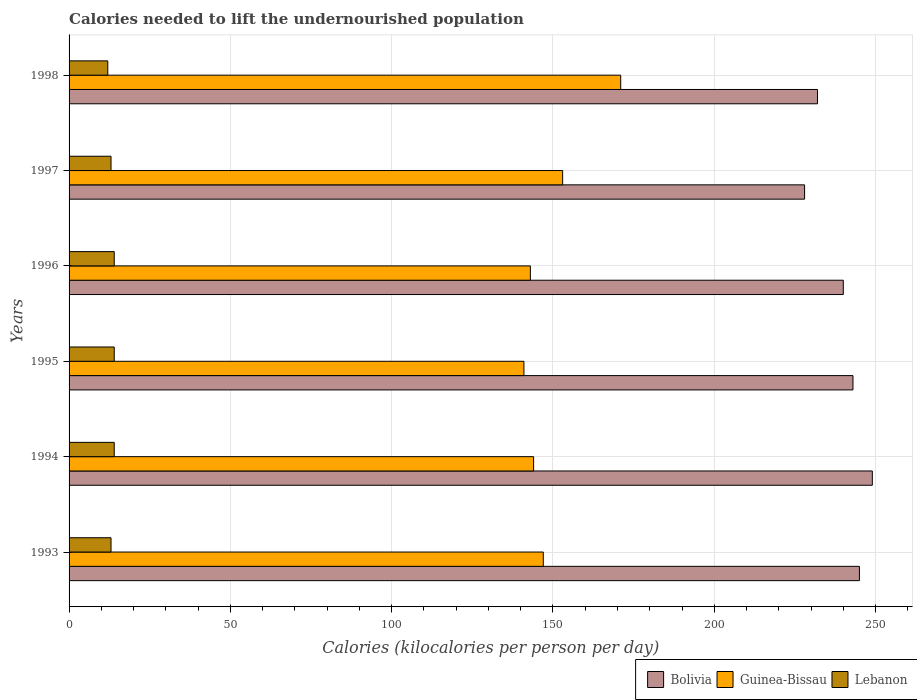How many different coloured bars are there?
Keep it short and to the point. 3. Are the number of bars per tick equal to the number of legend labels?
Make the answer very short. Yes. What is the total calories needed to lift the undernourished population in Lebanon in 1998?
Your answer should be very brief. 12. Across all years, what is the maximum total calories needed to lift the undernourished population in Guinea-Bissau?
Make the answer very short. 171. Across all years, what is the minimum total calories needed to lift the undernourished population in Lebanon?
Offer a very short reply. 12. In which year was the total calories needed to lift the undernourished population in Bolivia maximum?
Offer a terse response. 1994. What is the total total calories needed to lift the undernourished population in Lebanon in the graph?
Your response must be concise. 80. What is the difference between the total calories needed to lift the undernourished population in Guinea-Bissau in 1993 and the total calories needed to lift the undernourished population in Bolivia in 1995?
Offer a very short reply. -96. What is the average total calories needed to lift the undernourished population in Bolivia per year?
Provide a short and direct response. 239.5. In the year 1998, what is the difference between the total calories needed to lift the undernourished population in Lebanon and total calories needed to lift the undernourished population in Guinea-Bissau?
Your answer should be compact. -159. In how many years, is the total calories needed to lift the undernourished population in Lebanon greater than 50 kilocalories?
Provide a short and direct response. 0. What is the ratio of the total calories needed to lift the undernourished population in Bolivia in 1994 to that in 1997?
Provide a short and direct response. 1.09. What is the difference between the highest and the lowest total calories needed to lift the undernourished population in Bolivia?
Offer a terse response. 21. In how many years, is the total calories needed to lift the undernourished population in Lebanon greater than the average total calories needed to lift the undernourished population in Lebanon taken over all years?
Your answer should be compact. 3. Is the sum of the total calories needed to lift the undernourished population in Guinea-Bissau in 1994 and 1996 greater than the maximum total calories needed to lift the undernourished population in Lebanon across all years?
Offer a very short reply. Yes. What does the 2nd bar from the top in 1998 represents?
Your answer should be compact. Guinea-Bissau. What does the 1st bar from the bottom in 1998 represents?
Your answer should be compact. Bolivia. Are all the bars in the graph horizontal?
Offer a very short reply. Yes. Does the graph contain any zero values?
Keep it short and to the point. No. How many legend labels are there?
Ensure brevity in your answer.  3. What is the title of the graph?
Your response must be concise. Calories needed to lift the undernourished population. Does "Montenegro" appear as one of the legend labels in the graph?
Ensure brevity in your answer.  No. What is the label or title of the X-axis?
Your answer should be very brief. Calories (kilocalories per person per day). What is the Calories (kilocalories per person per day) in Bolivia in 1993?
Make the answer very short. 245. What is the Calories (kilocalories per person per day) in Guinea-Bissau in 1993?
Your answer should be compact. 147. What is the Calories (kilocalories per person per day) in Lebanon in 1993?
Your answer should be compact. 13. What is the Calories (kilocalories per person per day) in Bolivia in 1994?
Provide a succinct answer. 249. What is the Calories (kilocalories per person per day) in Guinea-Bissau in 1994?
Your answer should be very brief. 144. What is the Calories (kilocalories per person per day) in Bolivia in 1995?
Provide a succinct answer. 243. What is the Calories (kilocalories per person per day) in Guinea-Bissau in 1995?
Provide a short and direct response. 141. What is the Calories (kilocalories per person per day) of Bolivia in 1996?
Ensure brevity in your answer.  240. What is the Calories (kilocalories per person per day) in Guinea-Bissau in 1996?
Ensure brevity in your answer.  143. What is the Calories (kilocalories per person per day) in Lebanon in 1996?
Offer a very short reply. 14. What is the Calories (kilocalories per person per day) in Bolivia in 1997?
Your answer should be compact. 228. What is the Calories (kilocalories per person per day) in Guinea-Bissau in 1997?
Offer a terse response. 153. What is the Calories (kilocalories per person per day) of Bolivia in 1998?
Your answer should be compact. 232. What is the Calories (kilocalories per person per day) of Guinea-Bissau in 1998?
Keep it short and to the point. 171. What is the Calories (kilocalories per person per day) of Lebanon in 1998?
Give a very brief answer. 12. Across all years, what is the maximum Calories (kilocalories per person per day) of Bolivia?
Your response must be concise. 249. Across all years, what is the maximum Calories (kilocalories per person per day) in Guinea-Bissau?
Offer a terse response. 171. Across all years, what is the maximum Calories (kilocalories per person per day) in Lebanon?
Your response must be concise. 14. Across all years, what is the minimum Calories (kilocalories per person per day) of Bolivia?
Offer a very short reply. 228. Across all years, what is the minimum Calories (kilocalories per person per day) in Guinea-Bissau?
Keep it short and to the point. 141. Across all years, what is the minimum Calories (kilocalories per person per day) in Lebanon?
Provide a short and direct response. 12. What is the total Calories (kilocalories per person per day) of Bolivia in the graph?
Provide a short and direct response. 1437. What is the total Calories (kilocalories per person per day) in Guinea-Bissau in the graph?
Your answer should be very brief. 899. What is the total Calories (kilocalories per person per day) in Lebanon in the graph?
Your response must be concise. 80. What is the difference between the Calories (kilocalories per person per day) of Lebanon in 1993 and that in 1994?
Your response must be concise. -1. What is the difference between the Calories (kilocalories per person per day) in Bolivia in 1993 and that in 1995?
Your answer should be very brief. 2. What is the difference between the Calories (kilocalories per person per day) of Guinea-Bissau in 1993 and that in 1995?
Give a very brief answer. 6. What is the difference between the Calories (kilocalories per person per day) of Bolivia in 1993 and that in 1996?
Offer a very short reply. 5. What is the difference between the Calories (kilocalories per person per day) of Guinea-Bissau in 1993 and that in 1996?
Offer a terse response. 4. What is the difference between the Calories (kilocalories per person per day) in Lebanon in 1993 and that in 1997?
Make the answer very short. 0. What is the difference between the Calories (kilocalories per person per day) in Lebanon in 1993 and that in 1998?
Provide a succinct answer. 1. What is the difference between the Calories (kilocalories per person per day) of Lebanon in 1994 and that in 1995?
Your response must be concise. 0. What is the difference between the Calories (kilocalories per person per day) in Bolivia in 1994 and that in 1997?
Make the answer very short. 21. What is the difference between the Calories (kilocalories per person per day) of Lebanon in 1994 and that in 1997?
Ensure brevity in your answer.  1. What is the difference between the Calories (kilocalories per person per day) in Lebanon in 1994 and that in 1998?
Offer a terse response. 2. What is the difference between the Calories (kilocalories per person per day) in Bolivia in 1995 and that in 1996?
Offer a very short reply. 3. What is the difference between the Calories (kilocalories per person per day) of Bolivia in 1995 and that in 1997?
Provide a short and direct response. 15. What is the difference between the Calories (kilocalories per person per day) in Guinea-Bissau in 1995 and that in 1997?
Keep it short and to the point. -12. What is the difference between the Calories (kilocalories per person per day) of Lebanon in 1996 and that in 1997?
Offer a terse response. 1. What is the difference between the Calories (kilocalories per person per day) in Bolivia in 1997 and that in 1998?
Your answer should be very brief. -4. What is the difference between the Calories (kilocalories per person per day) of Guinea-Bissau in 1997 and that in 1998?
Offer a very short reply. -18. What is the difference between the Calories (kilocalories per person per day) in Lebanon in 1997 and that in 1998?
Offer a terse response. 1. What is the difference between the Calories (kilocalories per person per day) of Bolivia in 1993 and the Calories (kilocalories per person per day) of Guinea-Bissau in 1994?
Give a very brief answer. 101. What is the difference between the Calories (kilocalories per person per day) of Bolivia in 1993 and the Calories (kilocalories per person per day) of Lebanon in 1994?
Provide a short and direct response. 231. What is the difference between the Calories (kilocalories per person per day) in Guinea-Bissau in 1993 and the Calories (kilocalories per person per day) in Lebanon in 1994?
Your response must be concise. 133. What is the difference between the Calories (kilocalories per person per day) in Bolivia in 1993 and the Calories (kilocalories per person per day) in Guinea-Bissau in 1995?
Provide a short and direct response. 104. What is the difference between the Calories (kilocalories per person per day) of Bolivia in 1993 and the Calories (kilocalories per person per day) of Lebanon in 1995?
Ensure brevity in your answer.  231. What is the difference between the Calories (kilocalories per person per day) of Guinea-Bissau in 1993 and the Calories (kilocalories per person per day) of Lebanon in 1995?
Your answer should be compact. 133. What is the difference between the Calories (kilocalories per person per day) of Bolivia in 1993 and the Calories (kilocalories per person per day) of Guinea-Bissau in 1996?
Your response must be concise. 102. What is the difference between the Calories (kilocalories per person per day) in Bolivia in 1993 and the Calories (kilocalories per person per day) in Lebanon in 1996?
Your response must be concise. 231. What is the difference between the Calories (kilocalories per person per day) of Guinea-Bissau in 1993 and the Calories (kilocalories per person per day) of Lebanon in 1996?
Offer a terse response. 133. What is the difference between the Calories (kilocalories per person per day) of Bolivia in 1993 and the Calories (kilocalories per person per day) of Guinea-Bissau in 1997?
Offer a very short reply. 92. What is the difference between the Calories (kilocalories per person per day) of Bolivia in 1993 and the Calories (kilocalories per person per day) of Lebanon in 1997?
Your answer should be very brief. 232. What is the difference between the Calories (kilocalories per person per day) in Guinea-Bissau in 1993 and the Calories (kilocalories per person per day) in Lebanon in 1997?
Your response must be concise. 134. What is the difference between the Calories (kilocalories per person per day) of Bolivia in 1993 and the Calories (kilocalories per person per day) of Guinea-Bissau in 1998?
Offer a very short reply. 74. What is the difference between the Calories (kilocalories per person per day) of Bolivia in 1993 and the Calories (kilocalories per person per day) of Lebanon in 1998?
Your answer should be compact. 233. What is the difference between the Calories (kilocalories per person per day) in Guinea-Bissau in 1993 and the Calories (kilocalories per person per day) in Lebanon in 1998?
Ensure brevity in your answer.  135. What is the difference between the Calories (kilocalories per person per day) of Bolivia in 1994 and the Calories (kilocalories per person per day) of Guinea-Bissau in 1995?
Your answer should be compact. 108. What is the difference between the Calories (kilocalories per person per day) in Bolivia in 1994 and the Calories (kilocalories per person per day) in Lebanon in 1995?
Make the answer very short. 235. What is the difference between the Calories (kilocalories per person per day) in Guinea-Bissau in 1994 and the Calories (kilocalories per person per day) in Lebanon in 1995?
Provide a succinct answer. 130. What is the difference between the Calories (kilocalories per person per day) of Bolivia in 1994 and the Calories (kilocalories per person per day) of Guinea-Bissau in 1996?
Provide a short and direct response. 106. What is the difference between the Calories (kilocalories per person per day) in Bolivia in 1994 and the Calories (kilocalories per person per day) in Lebanon in 1996?
Offer a terse response. 235. What is the difference between the Calories (kilocalories per person per day) of Guinea-Bissau in 1994 and the Calories (kilocalories per person per day) of Lebanon in 1996?
Your answer should be compact. 130. What is the difference between the Calories (kilocalories per person per day) in Bolivia in 1994 and the Calories (kilocalories per person per day) in Guinea-Bissau in 1997?
Your answer should be very brief. 96. What is the difference between the Calories (kilocalories per person per day) of Bolivia in 1994 and the Calories (kilocalories per person per day) of Lebanon in 1997?
Your answer should be very brief. 236. What is the difference between the Calories (kilocalories per person per day) in Guinea-Bissau in 1994 and the Calories (kilocalories per person per day) in Lebanon in 1997?
Your response must be concise. 131. What is the difference between the Calories (kilocalories per person per day) in Bolivia in 1994 and the Calories (kilocalories per person per day) in Guinea-Bissau in 1998?
Provide a succinct answer. 78. What is the difference between the Calories (kilocalories per person per day) of Bolivia in 1994 and the Calories (kilocalories per person per day) of Lebanon in 1998?
Offer a terse response. 237. What is the difference between the Calories (kilocalories per person per day) of Guinea-Bissau in 1994 and the Calories (kilocalories per person per day) of Lebanon in 1998?
Keep it short and to the point. 132. What is the difference between the Calories (kilocalories per person per day) of Bolivia in 1995 and the Calories (kilocalories per person per day) of Lebanon in 1996?
Give a very brief answer. 229. What is the difference between the Calories (kilocalories per person per day) of Guinea-Bissau in 1995 and the Calories (kilocalories per person per day) of Lebanon in 1996?
Your answer should be compact. 127. What is the difference between the Calories (kilocalories per person per day) of Bolivia in 1995 and the Calories (kilocalories per person per day) of Lebanon in 1997?
Ensure brevity in your answer.  230. What is the difference between the Calories (kilocalories per person per day) in Guinea-Bissau in 1995 and the Calories (kilocalories per person per day) in Lebanon in 1997?
Your response must be concise. 128. What is the difference between the Calories (kilocalories per person per day) of Bolivia in 1995 and the Calories (kilocalories per person per day) of Lebanon in 1998?
Keep it short and to the point. 231. What is the difference between the Calories (kilocalories per person per day) of Guinea-Bissau in 1995 and the Calories (kilocalories per person per day) of Lebanon in 1998?
Offer a terse response. 129. What is the difference between the Calories (kilocalories per person per day) in Bolivia in 1996 and the Calories (kilocalories per person per day) in Lebanon in 1997?
Make the answer very short. 227. What is the difference between the Calories (kilocalories per person per day) in Guinea-Bissau in 1996 and the Calories (kilocalories per person per day) in Lebanon in 1997?
Keep it short and to the point. 130. What is the difference between the Calories (kilocalories per person per day) in Bolivia in 1996 and the Calories (kilocalories per person per day) in Guinea-Bissau in 1998?
Ensure brevity in your answer.  69. What is the difference between the Calories (kilocalories per person per day) in Bolivia in 1996 and the Calories (kilocalories per person per day) in Lebanon in 1998?
Offer a very short reply. 228. What is the difference between the Calories (kilocalories per person per day) in Guinea-Bissau in 1996 and the Calories (kilocalories per person per day) in Lebanon in 1998?
Your answer should be compact. 131. What is the difference between the Calories (kilocalories per person per day) of Bolivia in 1997 and the Calories (kilocalories per person per day) of Lebanon in 1998?
Provide a short and direct response. 216. What is the difference between the Calories (kilocalories per person per day) of Guinea-Bissau in 1997 and the Calories (kilocalories per person per day) of Lebanon in 1998?
Make the answer very short. 141. What is the average Calories (kilocalories per person per day) in Bolivia per year?
Offer a very short reply. 239.5. What is the average Calories (kilocalories per person per day) in Guinea-Bissau per year?
Your answer should be very brief. 149.83. What is the average Calories (kilocalories per person per day) of Lebanon per year?
Your answer should be very brief. 13.33. In the year 1993, what is the difference between the Calories (kilocalories per person per day) of Bolivia and Calories (kilocalories per person per day) of Lebanon?
Provide a short and direct response. 232. In the year 1993, what is the difference between the Calories (kilocalories per person per day) in Guinea-Bissau and Calories (kilocalories per person per day) in Lebanon?
Keep it short and to the point. 134. In the year 1994, what is the difference between the Calories (kilocalories per person per day) of Bolivia and Calories (kilocalories per person per day) of Guinea-Bissau?
Keep it short and to the point. 105. In the year 1994, what is the difference between the Calories (kilocalories per person per day) of Bolivia and Calories (kilocalories per person per day) of Lebanon?
Give a very brief answer. 235. In the year 1994, what is the difference between the Calories (kilocalories per person per day) in Guinea-Bissau and Calories (kilocalories per person per day) in Lebanon?
Your answer should be very brief. 130. In the year 1995, what is the difference between the Calories (kilocalories per person per day) of Bolivia and Calories (kilocalories per person per day) of Guinea-Bissau?
Provide a succinct answer. 102. In the year 1995, what is the difference between the Calories (kilocalories per person per day) in Bolivia and Calories (kilocalories per person per day) in Lebanon?
Provide a succinct answer. 229. In the year 1995, what is the difference between the Calories (kilocalories per person per day) in Guinea-Bissau and Calories (kilocalories per person per day) in Lebanon?
Make the answer very short. 127. In the year 1996, what is the difference between the Calories (kilocalories per person per day) of Bolivia and Calories (kilocalories per person per day) of Guinea-Bissau?
Provide a succinct answer. 97. In the year 1996, what is the difference between the Calories (kilocalories per person per day) in Bolivia and Calories (kilocalories per person per day) in Lebanon?
Provide a succinct answer. 226. In the year 1996, what is the difference between the Calories (kilocalories per person per day) of Guinea-Bissau and Calories (kilocalories per person per day) of Lebanon?
Make the answer very short. 129. In the year 1997, what is the difference between the Calories (kilocalories per person per day) in Bolivia and Calories (kilocalories per person per day) in Guinea-Bissau?
Offer a very short reply. 75. In the year 1997, what is the difference between the Calories (kilocalories per person per day) in Bolivia and Calories (kilocalories per person per day) in Lebanon?
Your answer should be very brief. 215. In the year 1997, what is the difference between the Calories (kilocalories per person per day) of Guinea-Bissau and Calories (kilocalories per person per day) of Lebanon?
Offer a very short reply. 140. In the year 1998, what is the difference between the Calories (kilocalories per person per day) of Bolivia and Calories (kilocalories per person per day) of Lebanon?
Offer a terse response. 220. In the year 1998, what is the difference between the Calories (kilocalories per person per day) in Guinea-Bissau and Calories (kilocalories per person per day) in Lebanon?
Provide a succinct answer. 159. What is the ratio of the Calories (kilocalories per person per day) of Bolivia in 1993 to that in 1994?
Your response must be concise. 0.98. What is the ratio of the Calories (kilocalories per person per day) of Guinea-Bissau in 1993 to that in 1994?
Offer a very short reply. 1.02. What is the ratio of the Calories (kilocalories per person per day) in Lebanon in 1993 to that in 1994?
Make the answer very short. 0.93. What is the ratio of the Calories (kilocalories per person per day) in Bolivia in 1993 to that in 1995?
Provide a short and direct response. 1.01. What is the ratio of the Calories (kilocalories per person per day) in Guinea-Bissau in 1993 to that in 1995?
Keep it short and to the point. 1.04. What is the ratio of the Calories (kilocalories per person per day) in Lebanon in 1993 to that in 1995?
Your response must be concise. 0.93. What is the ratio of the Calories (kilocalories per person per day) of Bolivia in 1993 to that in 1996?
Provide a succinct answer. 1.02. What is the ratio of the Calories (kilocalories per person per day) of Guinea-Bissau in 1993 to that in 1996?
Make the answer very short. 1.03. What is the ratio of the Calories (kilocalories per person per day) in Bolivia in 1993 to that in 1997?
Offer a very short reply. 1.07. What is the ratio of the Calories (kilocalories per person per day) of Guinea-Bissau in 1993 to that in 1997?
Your answer should be very brief. 0.96. What is the ratio of the Calories (kilocalories per person per day) of Lebanon in 1993 to that in 1997?
Your answer should be compact. 1. What is the ratio of the Calories (kilocalories per person per day) of Bolivia in 1993 to that in 1998?
Give a very brief answer. 1.06. What is the ratio of the Calories (kilocalories per person per day) in Guinea-Bissau in 1993 to that in 1998?
Provide a short and direct response. 0.86. What is the ratio of the Calories (kilocalories per person per day) in Lebanon in 1993 to that in 1998?
Provide a short and direct response. 1.08. What is the ratio of the Calories (kilocalories per person per day) of Bolivia in 1994 to that in 1995?
Provide a succinct answer. 1.02. What is the ratio of the Calories (kilocalories per person per day) in Guinea-Bissau in 1994 to that in 1995?
Provide a succinct answer. 1.02. What is the ratio of the Calories (kilocalories per person per day) in Lebanon in 1994 to that in 1995?
Offer a terse response. 1. What is the ratio of the Calories (kilocalories per person per day) of Bolivia in 1994 to that in 1996?
Provide a short and direct response. 1.04. What is the ratio of the Calories (kilocalories per person per day) of Lebanon in 1994 to that in 1996?
Provide a short and direct response. 1. What is the ratio of the Calories (kilocalories per person per day) in Bolivia in 1994 to that in 1997?
Provide a succinct answer. 1.09. What is the ratio of the Calories (kilocalories per person per day) of Lebanon in 1994 to that in 1997?
Provide a succinct answer. 1.08. What is the ratio of the Calories (kilocalories per person per day) in Bolivia in 1994 to that in 1998?
Make the answer very short. 1.07. What is the ratio of the Calories (kilocalories per person per day) of Guinea-Bissau in 1994 to that in 1998?
Make the answer very short. 0.84. What is the ratio of the Calories (kilocalories per person per day) of Lebanon in 1994 to that in 1998?
Provide a short and direct response. 1.17. What is the ratio of the Calories (kilocalories per person per day) of Bolivia in 1995 to that in 1996?
Your answer should be very brief. 1.01. What is the ratio of the Calories (kilocalories per person per day) in Guinea-Bissau in 1995 to that in 1996?
Provide a succinct answer. 0.99. What is the ratio of the Calories (kilocalories per person per day) in Lebanon in 1995 to that in 1996?
Keep it short and to the point. 1. What is the ratio of the Calories (kilocalories per person per day) in Bolivia in 1995 to that in 1997?
Make the answer very short. 1.07. What is the ratio of the Calories (kilocalories per person per day) in Guinea-Bissau in 1995 to that in 1997?
Ensure brevity in your answer.  0.92. What is the ratio of the Calories (kilocalories per person per day) in Bolivia in 1995 to that in 1998?
Your answer should be compact. 1.05. What is the ratio of the Calories (kilocalories per person per day) of Guinea-Bissau in 1995 to that in 1998?
Offer a terse response. 0.82. What is the ratio of the Calories (kilocalories per person per day) in Bolivia in 1996 to that in 1997?
Your response must be concise. 1.05. What is the ratio of the Calories (kilocalories per person per day) of Guinea-Bissau in 1996 to that in 1997?
Your answer should be very brief. 0.93. What is the ratio of the Calories (kilocalories per person per day) in Lebanon in 1996 to that in 1997?
Keep it short and to the point. 1.08. What is the ratio of the Calories (kilocalories per person per day) in Bolivia in 1996 to that in 1998?
Offer a very short reply. 1.03. What is the ratio of the Calories (kilocalories per person per day) of Guinea-Bissau in 1996 to that in 1998?
Offer a very short reply. 0.84. What is the ratio of the Calories (kilocalories per person per day) of Bolivia in 1997 to that in 1998?
Give a very brief answer. 0.98. What is the ratio of the Calories (kilocalories per person per day) in Guinea-Bissau in 1997 to that in 1998?
Make the answer very short. 0.89. What is the ratio of the Calories (kilocalories per person per day) in Lebanon in 1997 to that in 1998?
Your response must be concise. 1.08. What is the difference between the highest and the second highest Calories (kilocalories per person per day) of Bolivia?
Provide a short and direct response. 4. What is the difference between the highest and the second highest Calories (kilocalories per person per day) in Guinea-Bissau?
Provide a succinct answer. 18. What is the difference between the highest and the lowest Calories (kilocalories per person per day) of Bolivia?
Your response must be concise. 21. What is the difference between the highest and the lowest Calories (kilocalories per person per day) in Guinea-Bissau?
Your answer should be compact. 30. What is the difference between the highest and the lowest Calories (kilocalories per person per day) of Lebanon?
Make the answer very short. 2. 